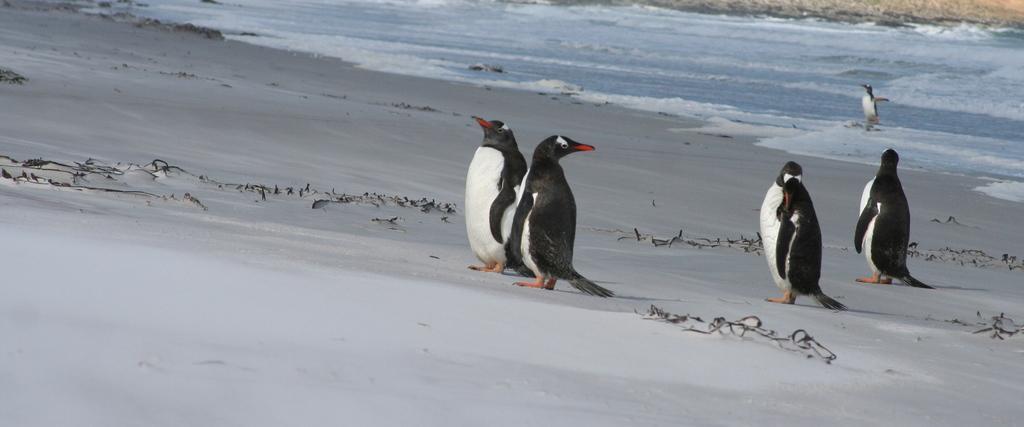Can you describe this image briefly? In this image, we can see some penguins and we can see water. 